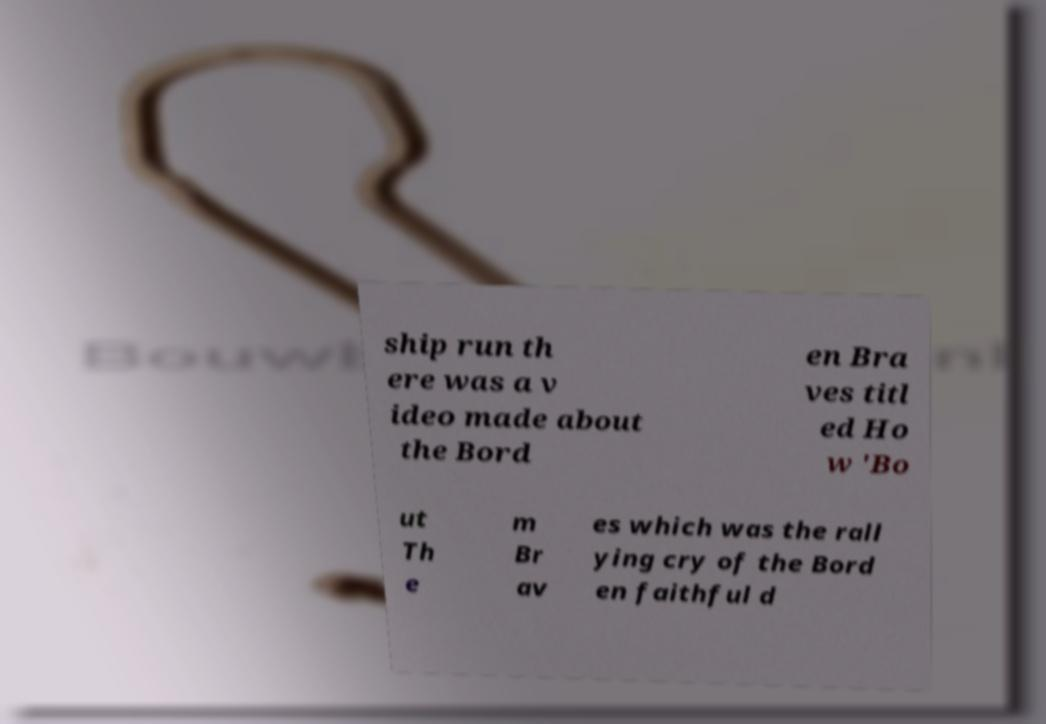There's text embedded in this image that I need extracted. Can you transcribe it verbatim? ship run th ere was a v ideo made about the Bord en Bra ves titl ed Ho w 'Bo ut Th e m Br av es which was the rall ying cry of the Bord en faithful d 